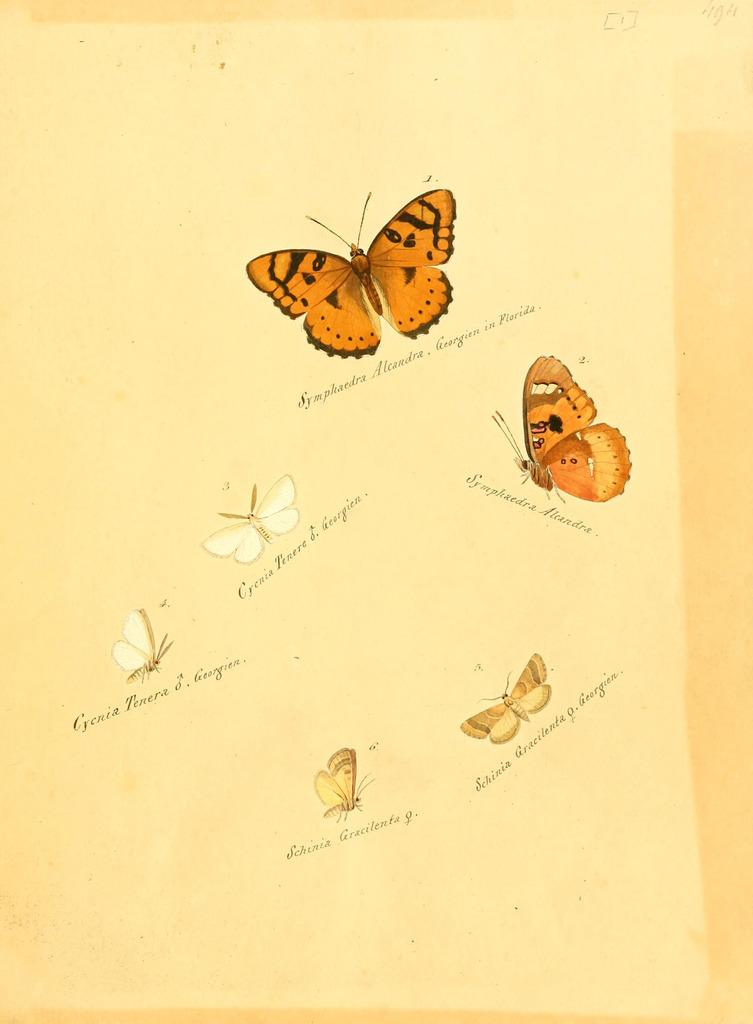What is depicted on the paper in the image? There are images of butterflies on a paper. What else can be seen on the paper besides the butterflies? There is text under the butterflies. What type of payment is being made in the image? There is no payment being made in the image; it only features images of butterflies and text. How many stars can be seen in the image? There are no stars present in the image. 